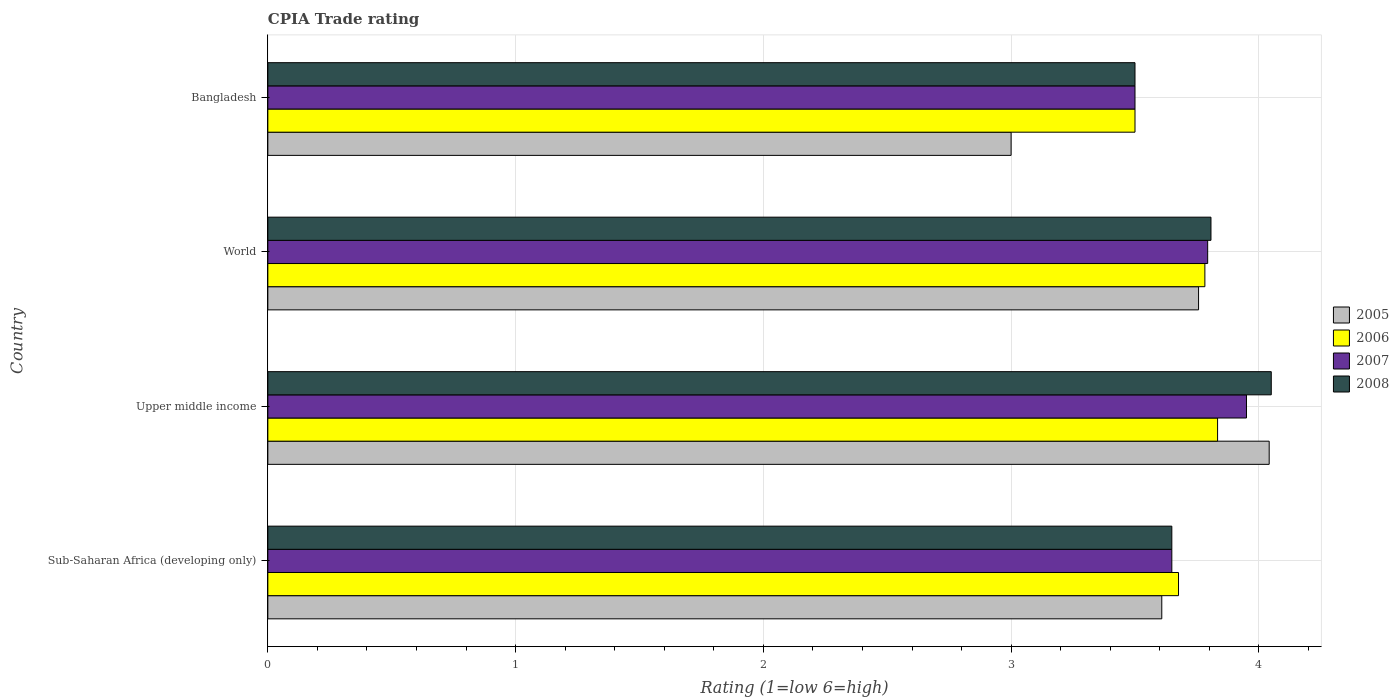How many groups of bars are there?
Offer a very short reply. 4. Are the number of bars on each tick of the Y-axis equal?
Offer a very short reply. Yes. How many bars are there on the 2nd tick from the top?
Give a very brief answer. 4. What is the label of the 1st group of bars from the top?
Your answer should be very brief. Bangladesh. In how many cases, is the number of bars for a given country not equal to the number of legend labels?
Provide a succinct answer. 0. What is the CPIA rating in 2005 in Upper middle income?
Ensure brevity in your answer.  4.04. Across all countries, what is the maximum CPIA rating in 2007?
Keep it short and to the point. 3.95. In which country was the CPIA rating in 2005 maximum?
Keep it short and to the point. Upper middle income. What is the total CPIA rating in 2008 in the graph?
Provide a succinct answer. 15.01. What is the difference between the CPIA rating in 2008 in Bangladesh and that in Sub-Saharan Africa (developing only)?
Your answer should be compact. -0.15. What is the difference between the CPIA rating in 2005 in Bangladesh and the CPIA rating in 2008 in Sub-Saharan Africa (developing only)?
Ensure brevity in your answer.  -0.65. What is the average CPIA rating in 2006 per country?
Your response must be concise. 3.7. What is the ratio of the CPIA rating in 2008 in Sub-Saharan Africa (developing only) to that in Upper middle income?
Ensure brevity in your answer.  0.9. Is the CPIA rating in 2005 in Bangladesh less than that in Upper middle income?
Provide a succinct answer. Yes. Is the difference between the CPIA rating in 2005 in Bangladesh and World greater than the difference between the CPIA rating in 2006 in Bangladesh and World?
Keep it short and to the point. No. What is the difference between the highest and the second highest CPIA rating in 2005?
Give a very brief answer. 0.29. What is the difference between the highest and the lowest CPIA rating in 2005?
Make the answer very short. 1.04. In how many countries, is the CPIA rating in 2007 greater than the average CPIA rating in 2007 taken over all countries?
Your response must be concise. 2. Is it the case that in every country, the sum of the CPIA rating in 2005 and CPIA rating in 2006 is greater than the sum of CPIA rating in 2008 and CPIA rating in 2007?
Keep it short and to the point. No. What does the 1st bar from the bottom in Upper middle income represents?
Offer a very short reply. 2005. Is it the case that in every country, the sum of the CPIA rating in 2007 and CPIA rating in 2008 is greater than the CPIA rating in 2006?
Your answer should be compact. Yes. How many bars are there?
Your answer should be very brief. 16. Are all the bars in the graph horizontal?
Keep it short and to the point. Yes. Does the graph contain any zero values?
Keep it short and to the point. No. How many legend labels are there?
Give a very brief answer. 4. How are the legend labels stacked?
Give a very brief answer. Vertical. What is the title of the graph?
Your answer should be very brief. CPIA Trade rating. Does "1993" appear as one of the legend labels in the graph?
Your answer should be very brief. No. What is the Rating (1=low 6=high) of 2005 in Sub-Saharan Africa (developing only)?
Your answer should be compact. 3.61. What is the Rating (1=low 6=high) in 2006 in Sub-Saharan Africa (developing only)?
Ensure brevity in your answer.  3.68. What is the Rating (1=low 6=high) in 2007 in Sub-Saharan Africa (developing only)?
Give a very brief answer. 3.65. What is the Rating (1=low 6=high) in 2008 in Sub-Saharan Africa (developing only)?
Keep it short and to the point. 3.65. What is the Rating (1=low 6=high) in 2005 in Upper middle income?
Your answer should be very brief. 4.04. What is the Rating (1=low 6=high) of 2006 in Upper middle income?
Offer a terse response. 3.83. What is the Rating (1=low 6=high) in 2007 in Upper middle income?
Make the answer very short. 3.95. What is the Rating (1=low 6=high) of 2008 in Upper middle income?
Your answer should be very brief. 4.05. What is the Rating (1=low 6=high) of 2005 in World?
Provide a short and direct response. 3.76. What is the Rating (1=low 6=high) in 2006 in World?
Your answer should be compact. 3.78. What is the Rating (1=low 6=high) in 2007 in World?
Offer a terse response. 3.79. What is the Rating (1=low 6=high) in 2008 in World?
Make the answer very short. 3.81. What is the Rating (1=low 6=high) in 2005 in Bangladesh?
Ensure brevity in your answer.  3. What is the Rating (1=low 6=high) of 2006 in Bangladesh?
Provide a succinct answer. 3.5. What is the Rating (1=low 6=high) of 2007 in Bangladesh?
Your response must be concise. 3.5. Across all countries, what is the maximum Rating (1=low 6=high) of 2005?
Offer a terse response. 4.04. Across all countries, what is the maximum Rating (1=low 6=high) of 2006?
Your response must be concise. 3.83. Across all countries, what is the maximum Rating (1=low 6=high) of 2007?
Offer a terse response. 3.95. Across all countries, what is the maximum Rating (1=low 6=high) in 2008?
Make the answer very short. 4.05. Across all countries, what is the minimum Rating (1=low 6=high) of 2005?
Provide a short and direct response. 3. Across all countries, what is the minimum Rating (1=low 6=high) in 2006?
Your response must be concise. 3.5. Across all countries, what is the minimum Rating (1=low 6=high) of 2008?
Make the answer very short. 3.5. What is the total Rating (1=low 6=high) in 2005 in the graph?
Offer a terse response. 14.41. What is the total Rating (1=low 6=high) of 2006 in the graph?
Keep it short and to the point. 14.79. What is the total Rating (1=low 6=high) of 2007 in the graph?
Your response must be concise. 14.89. What is the total Rating (1=low 6=high) of 2008 in the graph?
Offer a very short reply. 15.01. What is the difference between the Rating (1=low 6=high) in 2005 in Sub-Saharan Africa (developing only) and that in Upper middle income?
Your answer should be compact. -0.43. What is the difference between the Rating (1=low 6=high) of 2006 in Sub-Saharan Africa (developing only) and that in Upper middle income?
Give a very brief answer. -0.16. What is the difference between the Rating (1=low 6=high) of 2007 in Sub-Saharan Africa (developing only) and that in Upper middle income?
Your response must be concise. -0.3. What is the difference between the Rating (1=low 6=high) of 2008 in Sub-Saharan Africa (developing only) and that in Upper middle income?
Ensure brevity in your answer.  -0.4. What is the difference between the Rating (1=low 6=high) in 2005 in Sub-Saharan Africa (developing only) and that in World?
Offer a very short reply. -0.15. What is the difference between the Rating (1=low 6=high) in 2006 in Sub-Saharan Africa (developing only) and that in World?
Your answer should be very brief. -0.11. What is the difference between the Rating (1=low 6=high) in 2007 in Sub-Saharan Africa (developing only) and that in World?
Offer a terse response. -0.14. What is the difference between the Rating (1=low 6=high) in 2008 in Sub-Saharan Africa (developing only) and that in World?
Provide a short and direct response. -0.16. What is the difference between the Rating (1=low 6=high) of 2005 in Sub-Saharan Africa (developing only) and that in Bangladesh?
Provide a succinct answer. 0.61. What is the difference between the Rating (1=low 6=high) in 2006 in Sub-Saharan Africa (developing only) and that in Bangladesh?
Your answer should be compact. 0.18. What is the difference between the Rating (1=low 6=high) in 2007 in Sub-Saharan Africa (developing only) and that in Bangladesh?
Keep it short and to the point. 0.15. What is the difference between the Rating (1=low 6=high) of 2008 in Sub-Saharan Africa (developing only) and that in Bangladesh?
Provide a succinct answer. 0.15. What is the difference between the Rating (1=low 6=high) of 2005 in Upper middle income and that in World?
Your answer should be very brief. 0.29. What is the difference between the Rating (1=low 6=high) in 2006 in Upper middle income and that in World?
Provide a succinct answer. 0.05. What is the difference between the Rating (1=low 6=high) in 2007 in Upper middle income and that in World?
Your answer should be very brief. 0.16. What is the difference between the Rating (1=low 6=high) of 2008 in Upper middle income and that in World?
Give a very brief answer. 0.24. What is the difference between the Rating (1=low 6=high) of 2005 in Upper middle income and that in Bangladesh?
Your response must be concise. 1.04. What is the difference between the Rating (1=low 6=high) of 2007 in Upper middle income and that in Bangladesh?
Offer a very short reply. 0.45. What is the difference between the Rating (1=low 6=high) in 2008 in Upper middle income and that in Bangladesh?
Your response must be concise. 0.55. What is the difference between the Rating (1=low 6=high) of 2005 in World and that in Bangladesh?
Offer a very short reply. 0.76. What is the difference between the Rating (1=low 6=high) of 2006 in World and that in Bangladesh?
Offer a terse response. 0.28. What is the difference between the Rating (1=low 6=high) of 2007 in World and that in Bangladesh?
Provide a short and direct response. 0.29. What is the difference between the Rating (1=low 6=high) of 2008 in World and that in Bangladesh?
Provide a short and direct response. 0.31. What is the difference between the Rating (1=low 6=high) of 2005 in Sub-Saharan Africa (developing only) and the Rating (1=low 6=high) of 2006 in Upper middle income?
Provide a succinct answer. -0.23. What is the difference between the Rating (1=low 6=high) of 2005 in Sub-Saharan Africa (developing only) and the Rating (1=low 6=high) of 2007 in Upper middle income?
Make the answer very short. -0.34. What is the difference between the Rating (1=low 6=high) in 2005 in Sub-Saharan Africa (developing only) and the Rating (1=low 6=high) in 2008 in Upper middle income?
Ensure brevity in your answer.  -0.44. What is the difference between the Rating (1=low 6=high) of 2006 in Sub-Saharan Africa (developing only) and the Rating (1=low 6=high) of 2007 in Upper middle income?
Your response must be concise. -0.27. What is the difference between the Rating (1=low 6=high) in 2006 in Sub-Saharan Africa (developing only) and the Rating (1=low 6=high) in 2008 in Upper middle income?
Offer a very short reply. -0.37. What is the difference between the Rating (1=low 6=high) in 2007 in Sub-Saharan Africa (developing only) and the Rating (1=low 6=high) in 2008 in Upper middle income?
Offer a very short reply. -0.4. What is the difference between the Rating (1=low 6=high) of 2005 in Sub-Saharan Africa (developing only) and the Rating (1=low 6=high) of 2006 in World?
Your answer should be compact. -0.17. What is the difference between the Rating (1=low 6=high) of 2005 in Sub-Saharan Africa (developing only) and the Rating (1=low 6=high) of 2007 in World?
Offer a terse response. -0.19. What is the difference between the Rating (1=low 6=high) of 2005 in Sub-Saharan Africa (developing only) and the Rating (1=low 6=high) of 2008 in World?
Keep it short and to the point. -0.2. What is the difference between the Rating (1=low 6=high) in 2006 in Sub-Saharan Africa (developing only) and the Rating (1=low 6=high) in 2007 in World?
Your answer should be compact. -0.12. What is the difference between the Rating (1=low 6=high) in 2006 in Sub-Saharan Africa (developing only) and the Rating (1=low 6=high) in 2008 in World?
Ensure brevity in your answer.  -0.13. What is the difference between the Rating (1=low 6=high) of 2007 in Sub-Saharan Africa (developing only) and the Rating (1=low 6=high) of 2008 in World?
Your response must be concise. -0.16. What is the difference between the Rating (1=low 6=high) of 2005 in Sub-Saharan Africa (developing only) and the Rating (1=low 6=high) of 2006 in Bangladesh?
Give a very brief answer. 0.11. What is the difference between the Rating (1=low 6=high) in 2005 in Sub-Saharan Africa (developing only) and the Rating (1=low 6=high) in 2007 in Bangladesh?
Keep it short and to the point. 0.11. What is the difference between the Rating (1=low 6=high) in 2005 in Sub-Saharan Africa (developing only) and the Rating (1=low 6=high) in 2008 in Bangladesh?
Make the answer very short. 0.11. What is the difference between the Rating (1=low 6=high) of 2006 in Sub-Saharan Africa (developing only) and the Rating (1=low 6=high) of 2007 in Bangladesh?
Keep it short and to the point. 0.18. What is the difference between the Rating (1=low 6=high) in 2006 in Sub-Saharan Africa (developing only) and the Rating (1=low 6=high) in 2008 in Bangladesh?
Your answer should be compact. 0.18. What is the difference between the Rating (1=low 6=high) in 2007 in Sub-Saharan Africa (developing only) and the Rating (1=low 6=high) in 2008 in Bangladesh?
Your response must be concise. 0.15. What is the difference between the Rating (1=low 6=high) of 2005 in Upper middle income and the Rating (1=low 6=high) of 2006 in World?
Your response must be concise. 0.26. What is the difference between the Rating (1=low 6=high) in 2005 in Upper middle income and the Rating (1=low 6=high) in 2007 in World?
Provide a short and direct response. 0.25. What is the difference between the Rating (1=low 6=high) in 2005 in Upper middle income and the Rating (1=low 6=high) in 2008 in World?
Provide a short and direct response. 0.23. What is the difference between the Rating (1=low 6=high) of 2006 in Upper middle income and the Rating (1=low 6=high) of 2008 in World?
Your answer should be compact. 0.03. What is the difference between the Rating (1=low 6=high) in 2007 in Upper middle income and the Rating (1=low 6=high) in 2008 in World?
Make the answer very short. 0.14. What is the difference between the Rating (1=low 6=high) in 2005 in Upper middle income and the Rating (1=low 6=high) in 2006 in Bangladesh?
Keep it short and to the point. 0.54. What is the difference between the Rating (1=low 6=high) of 2005 in Upper middle income and the Rating (1=low 6=high) of 2007 in Bangladesh?
Ensure brevity in your answer.  0.54. What is the difference between the Rating (1=low 6=high) of 2005 in Upper middle income and the Rating (1=low 6=high) of 2008 in Bangladesh?
Your answer should be compact. 0.54. What is the difference between the Rating (1=low 6=high) of 2006 in Upper middle income and the Rating (1=low 6=high) of 2007 in Bangladesh?
Provide a short and direct response. 0.33. What is the difference between the Rating (1=low 6=high) of 2007 in Upper middle income and the Rating (1=low 6=high) of 2008 in Bangladesh?
Offer a very short reply. 0.45. What is the difference between the Rating (1=low 6=high) in 2005 in World and the Rating (1=low 6=high) in 2006 in Bangladesh?
Offer a terse response. 0.26. What is the difference between the Rating (1=low 6=high) in 2005 in World and the Rating (1=low 6=high) in 2007 in Bangladesh?
Your answer should be very brief. 0.26. What is the difference between the Rating (1=low 6=high) in 2005 in World and the Rating (1=low 6=high) in 2008 in Bangladesh?
Your answer should be compact. 0.26. What is the difference between the Rating (1=low 6=high) of 2006 in World and the Rating (1=low 6=high) of 2007 in Bangladesh?
Your answer should be compact. 0.28. What is the difference between the Rating (1=low 6=high) of 2006 in World and the Rating (1=low 6=high) of 2008 in Bangladesh?
Provide a succinct answer. 0.28. What is the difference between the Rating (1=low 6=high) in 2007 in World and the Rating (1=low 6=high) in 2008 in Bangladesh?
Your response must be concise. 0.29. What is the average Rating (1=low 6=high) of 2005 per country?
Ensure brevity in your answer.  3.6. What is the average Rating (1=low 6=high) of 2006 per country?
Provide a short and direct response. 3.7. What is the average Rating (1=low 6=high) of 2007 per country?
Keep it short and to the point. 3.72. What is the average Rating (1=low 6=high) of 2008 per country?
Provide a short and direct response. 3.75. What is the difference between the Rating (1=low 6=high) of 2005 and Rating (1=low 6=high) of 2006 in Sub-Saharan Africa (developing only)?
Offer a very short reply. -0.07. What is the difference between the Rating (1=low 6=high) in 2005 and Rating (1=low 6=high) in 2007 in Sub-Saharan Africa (developing only)?
Provide a succinct answer. -0.04. What is the difference between the Rating (1=low 6=high) of 2005 and Rating (1=low 6=high) of 2008 in Sub-Saharan Africa (developing only)?
Give a very brief answer. -0.04. What is the difference between the Rating (1=low 6=high) of 2006 and Rating (1=low 6=high) of 2007 in Sub-Saharan Africa (developing only)?
Offer a terse response. 0.03. What is the difference between the Rating (1=low 6=high) in 2006 and Rating (1=low 6=high) in 2008 in Sub-Saharan Africa (developing only)?
Keep it short and to the point. 0.03. What is the difference between the Rating (1=low 6=high) in 2007 and Rating (1=low 6=high) in 2008 in Sub-Saharan Africa (developing only)?
Your answer should be very brief. 0. What is the difference between the Rating (1=low 6=high) of 2005 and Rating (1=low 6=high) of 2006 in Upper middle income?
Provide a short and direct response. 0.21. What is the difference between the Rating (1=low 6=high) in 2005 and Rating (1=low 6=high) in 2007 in Upper middle income?
Keep it short and to the point. 0.09. What is the difference between the Rating (1=low 6=high) in 2005 and Rating (1=low 6=high) in 2008 in Upper middle income?
Provide a succinct answer. -0.01. What is the difference between the Rating (1=low 6=high) of 2006 and Rating (1=low 6=high) of 2007 in Upper middle income?
Your response must be concise. -0.12. What is the difference between the Rating (1=low 6=high) of 2006 and Rating (1=low 6=high) of 2008 in Upper middle income?
Your response must be concise. -0.22. What is the difference between the Rating (1=low 6=high) in 2007 and Rating (1=low 6=high) in 2008 in Upper middle income?
Make the answer very short. -0.1. What is the difference between the Rating (1=low 6=high) in 2005 and Rating (1=low 6=high) in 2006 in World?
Offer a very short reply. -0.03. What is the difference between the Rating (1=low 6=high) of 2005 and Rating (1=low 6=high) of 2007 in World?
Provide a succinct answer. -0.04. What is the difference between the Rating (1=low 6=high) of 2005 and Rating (1=low 6=high) of 2008 in World?
Offer a terse response. -0.05. What is the difference between the Rating (1=low 6=high) in 2006 and Rating (1=low 6=high) in 2007 in World?
Offer a terse response. -0.01. What is the difference between the Rating (1=low 6=high) in 2006 and Rating (1=low 6=high) in 2008 in World?
Your answer should be compact. -0.02. What is the difference between the Rating (1=low 6=high) of 2007 and Rating (1=low 6=high) of 2008 in World?
Provide a succinct answer. -0.01. What is the ratio of the Rating (1=low 6=high) of 2005 in Sub-Saharan Africa (developing only) to that in Upper middle income?
Offer a very short reply. 0.89. What is the ratio of the Rating (1=low 6=high) of 2006 in Sub-Saharan Africa (developing only) to that in Upper middle income?
Give a very brief answer. 0.96. What is the ratio of the Rating (1=low 6=high) of 2007 in Sub-Saharan Africa (developing only) to that in Upper middle income?
Offer a very short reply. 0.92. What is the ratio of the Rating (1=low 6=high) in 2008 in Sub-Saharan Africa (developing only) to that in Upper middle income?
Provide a short and direct response. 0.9. What is the ratio of the Rating (1=low 6=high) in 2005 in Sub-Saharan Africa (developing only) to that in World?
Give a very brief answer. 0.96. What is the ratio of the Rating (1=low 6=high) in 2006 in Sub-Saharan Africa (developing only) to that in World?
Offer a terse response. 0.97. What is the ratio of the Rating (1=low 6=high) in 2007 in Sub-Saharan Africa (developing only) to that in World?
Provide a short and direct response. 0.96. What is the ratio of the Rating (1=low 6=high) in 2008 in Sub-Saharan Africa (developing only) to that in World?
Your answer should be very brief. 0.96. What is the ratio of the Rating (1=low 6=high) in 2005 in Sub-Saharan Africa (developing only) to that in Bangladesh?
Offer a very short reply. 1.2. What is the ratio of the Rating (1=low 6=high) of 2006 in Sub-Saharan Africa (developing only) to that in Bangladesh?
Offer a terse response. 1.05. What is the ratio of the Rating (1=low 6=high) in 2007 in Sub-Saharan Africa (developing only) to that in Bangladesh?
Give a very brief answer. 1.04. What is the ratio of the Rating (1=low 6=high) in 2008 in Sub-Saharan Africa (developing only) to that in Bangladesh?
Make the answer very short. 1.04. What is the ratio of the Rating (1=low 6=high) in 2005 in Upper middle income to that in World?
Offer a terse response. 1.08. What is the ratio of the Rating (1=low 6=high) of 2006 in Upper middle income to that in World?
Keep it short and to the point. 1.01. What is the ratio of the Rating (1=low 6=high) of 2007 in Upper middle income to that in World?
Keep it short and to the point. 1.04. What is the ratio of the Rating (1=low 6=high) in 2008 in Upper middle income to that in World?
Your answer should be compact. 1.06. What is the ratio of the Rating (1=low 6=high) in 2005 in Upper middle income to that in Bangladesh?
Offer a terse response. 1.35. What is the ratio of the Rating (1=low 6=high) of 2006 in Upper middle income to that in Bangladesh?
Give a very brief answer. 1.1. What is the ratio of the Rating (1=low 6=high) in 2007 in Upper middle income to that in Bangladesh?
Make the answer very short. 1.13. What is the ratio of the Rating (1=low 6=high) of 2008 in Upper middle income to that in Bangladesh?
Make the answer very short. 1.16. What is the ratio of the Rating (1=low 6=high) of 2005 in World to that in Bangladesh?
Your answer should be very brief. 1.25. What is the ratio of the Rating (1=low 6=high) in 2006 in World to that in Bangladesh?
Provide a short and direct response. 1.08. What is the ratio of the Rating (1=low 6=high) of 2007 in World to that in Bangladesh?
Provide a short and direct response. 1.08. What is the ratio of the Rating (1=low 6=high) of 2008 in World to that in Bangladesh?
Provide a short and direct response. 1.09. What is the difference between the highest and the second highest Rating (1=low 6=high) in 2005?
Your response must be concise. 0.29. What is the difference between the highest and the second highest Rating (1=low 6=high) of 2006?
Your answer should be compact. 0.05. What is the difference between the highest and the second highest Rating (1=low 6=high) of 2007?
Your answer should be very brief. 0.16. What is the difference between the highest and the second highest Rating (1=low 6=high) of 2008?
Offer a very short reply. 0.24. What is the difference between the highest and the lowest Rating (1=low 6=high) in 2005?
Provide a short and direct response. 1.04. What is the difference between the highest and the lowest Rating (1=low 6=high) in 2006?
Give a very brief answer. 0.33. What is the difference between the highest and the lowest Rating (1=low 6=high) of 2007?
Offer a very short reply. 0.45. What is the difference between the highest and the lowest Rating (1=low 6=high) of 2008?
Your answer should be very brief. 0.55. 